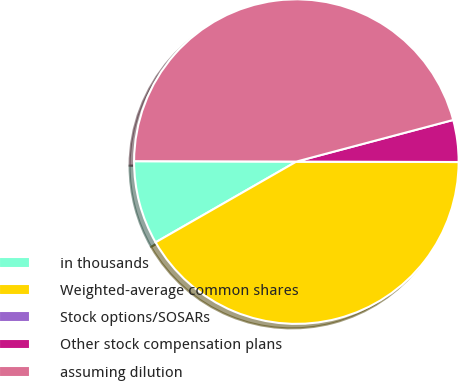<chart> <loc_0><loc_0><loc_500><loc_500><pie_chart><fcel>in thousands<fcel>Weighted-average common shares<fcel>Stock options/SOSARs<fcel>Other stock compensation plans<fcel>assuming dilution<nl><fcel>8.33%<fcel>41.67%<fcel>0.0%<fcel>4.17%<fcel>45.83%<nl></chart> 